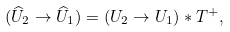<formula> <loc_0><loc_0><loc_500><loc_500>( \widehat { U } _ { 2 } \rightarrow \widehat { U } _ { 1 } ) = ( U _ { 2 } \rightarrow U _ { 1 } ) \ast T ^ { + } ,</formula> 